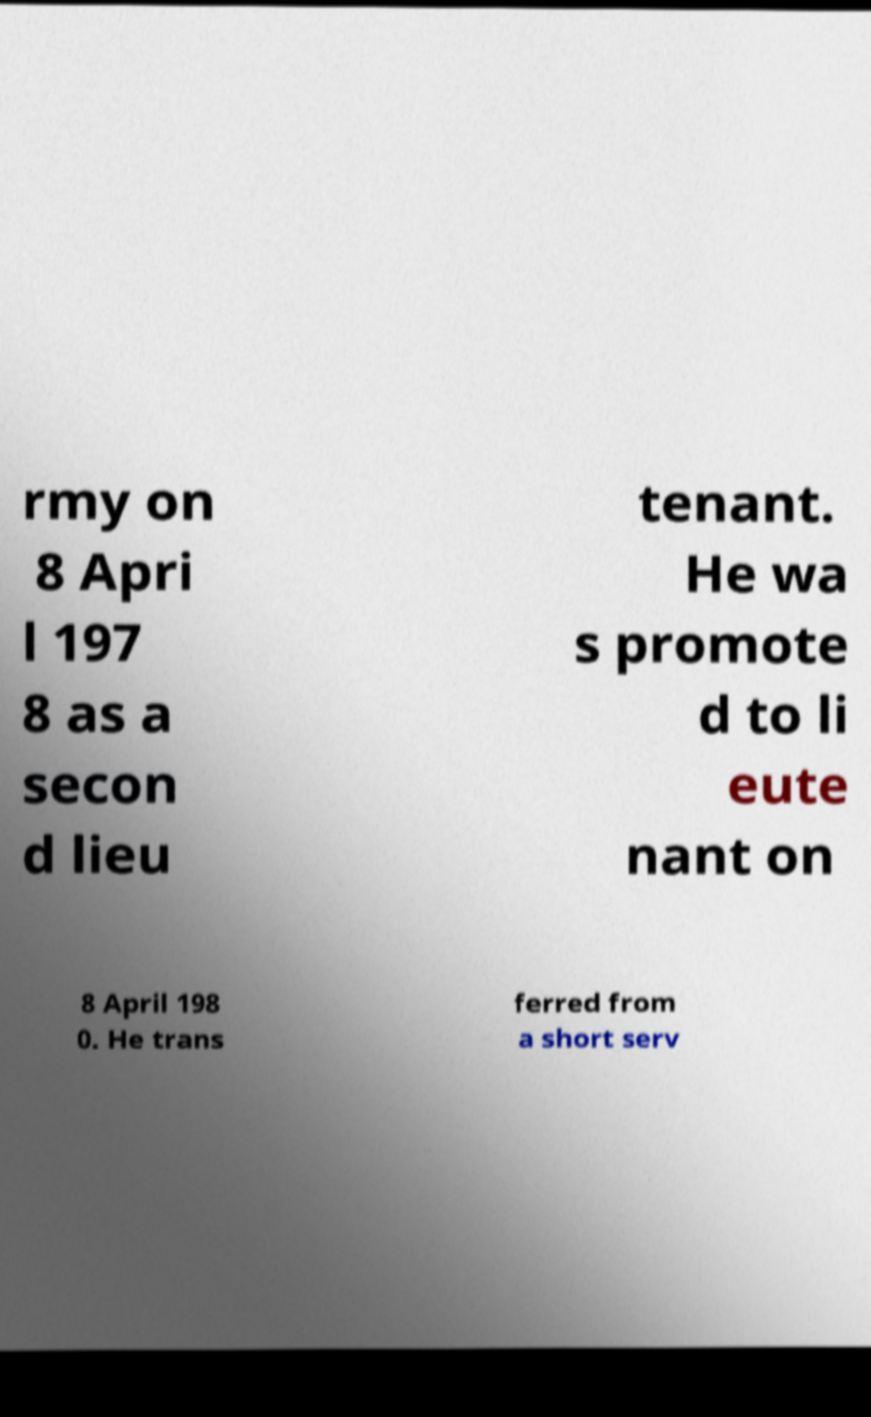For documentation purposes, I need the text within this image transcribed. Could you provide that? rmy on 8 Apri l 197 8 as a secon d lieu tenant. He wa s promote d to li eute nant on 8 April 198 0. He trans ferred from a short serv 